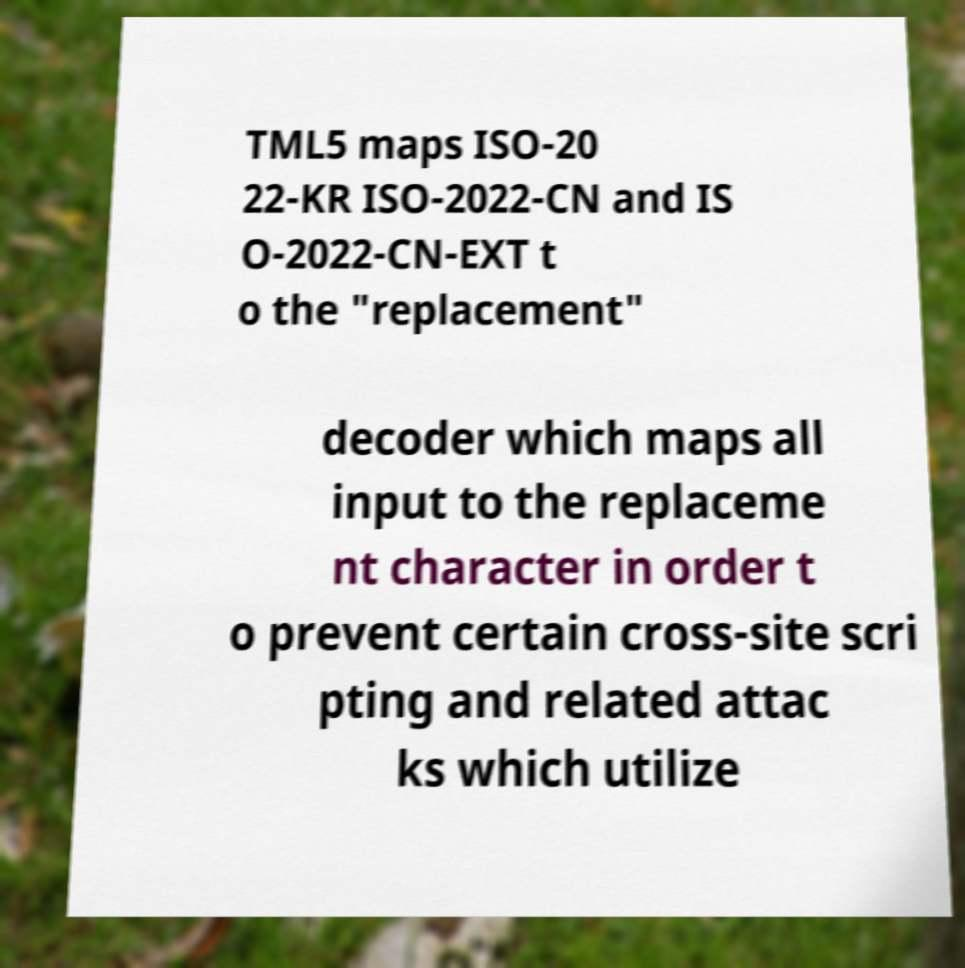For documentation purposes, I need the text within this image transcribed. Could you provide that? TML5 maps ISO-20 22-KR ISO-2022-CN and IS O-2022-CN-EXT t o the "replacement" decoder which maps all input to the replaceme nt character in order t o prevent certain cross-site scri pting and related attac ks which utilize 